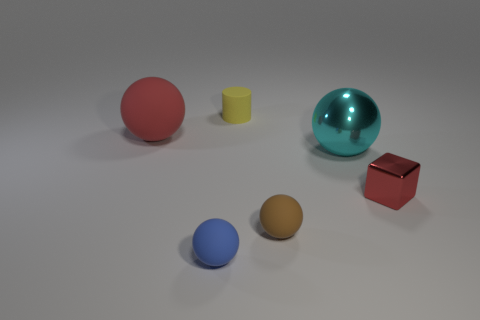What size is the rubber thing that is the same color as the small block?
Your answer should be very brief. Large. Do the shiny block and the big matte thing have the same color?
Provide a succinct answer. Yes. How many red things are either large balls or big matte cylinders?
Your answer should be compact. 1. There is a rubber sphere behind the small red metallic cube; is its color the same as the small metallic object?
Keep it short and to the point. Yes. What is the size of the ball right of the rubber sphere on the right side of the small blue matte thing?
Ensure brevity in your answer.  Large. There is a red thing that is the same size as the cylinder; what material is it?
Offer a terse response. Metal. What number of other objects are the same size as the block?
Offer a very short reply. 3. What number of cubes are blue rubber objects or small gray matte things?
Your answer should be compact. 0. There is a big sphere that is right of the matte object behind the matte ball that is behind the cyan thing; what is it made of?
Your answer should be compact. Metal. What material is the other thing that is the same color as the big rubber thing?
Offer a very short reply. Metal. 